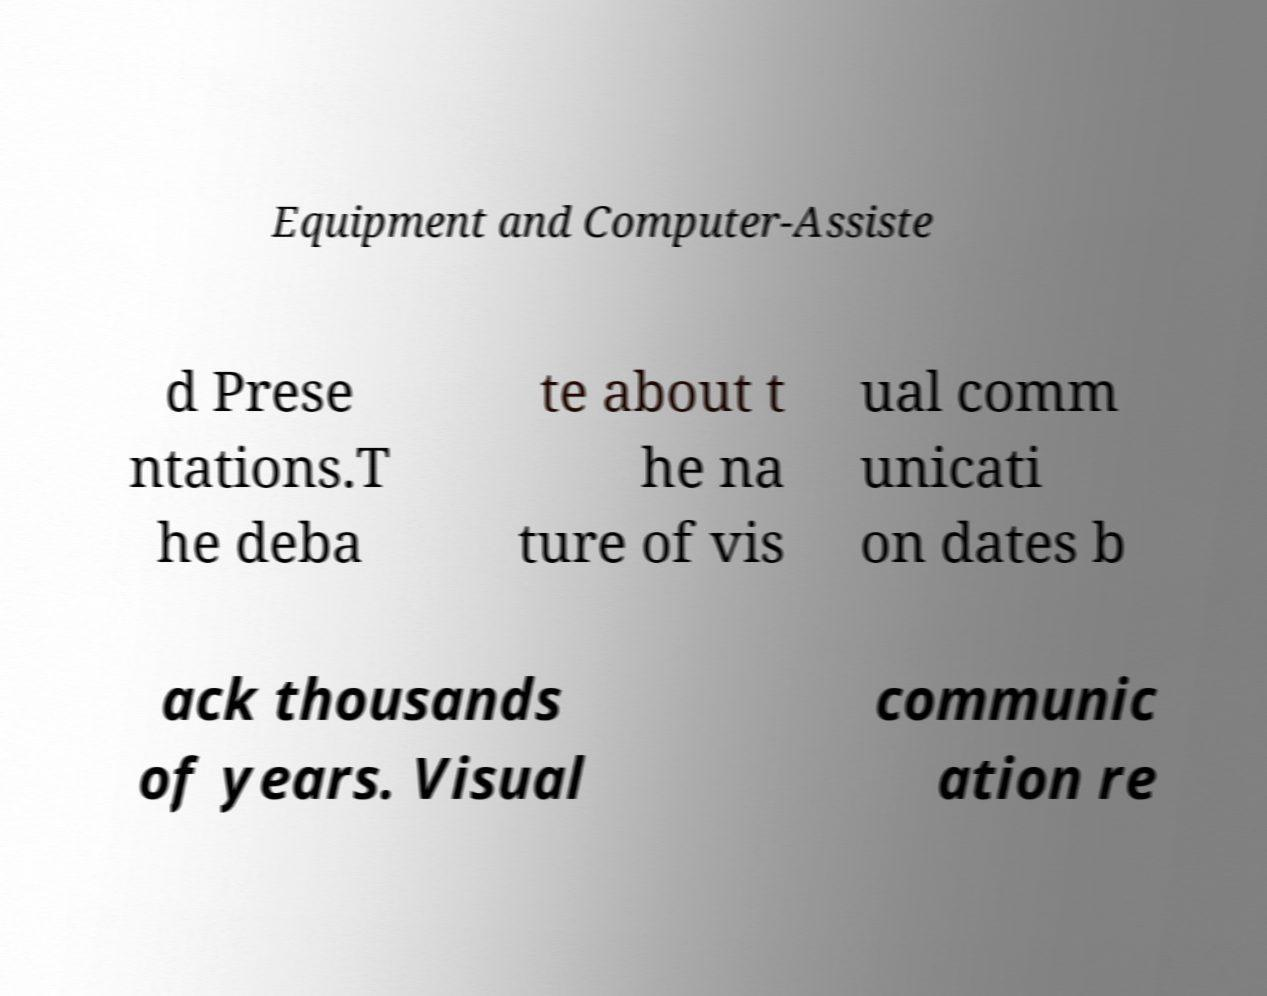Could you extract and type out the text from this image? Equipment and Computer-Assiste d Prese ntations.T he deba te about t he na ture of vis ual comm unicati on dates b ack thousands of years. Visual communic ation re 